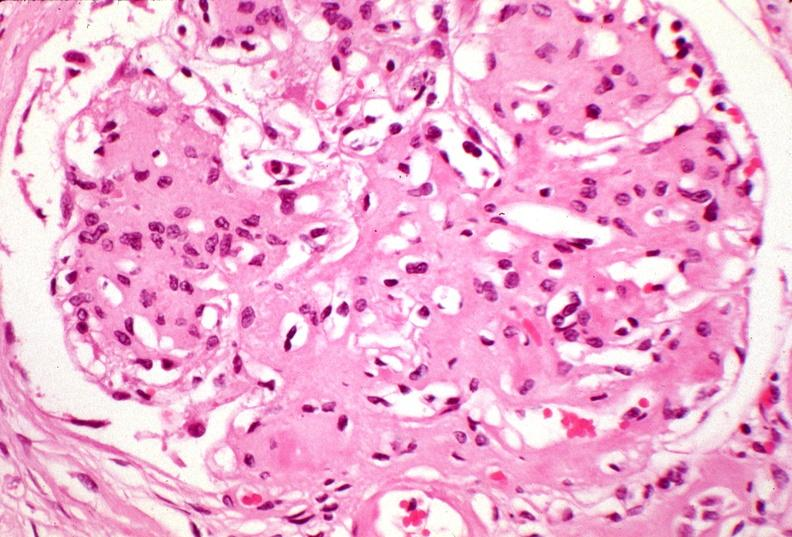what does this image show?
Answer the question using a single word or phrase. Kidney 